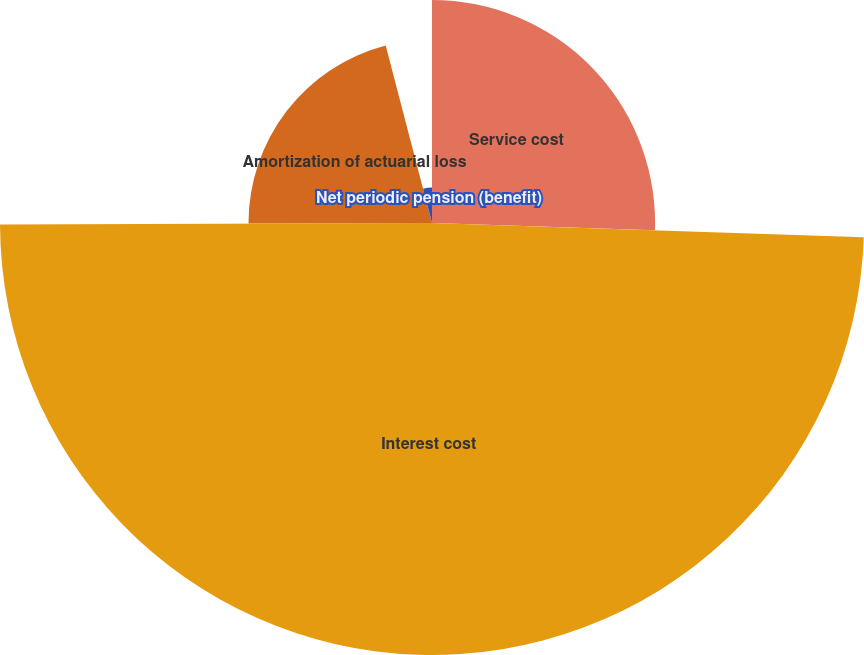<chart> <loc_0><loc_0><loc_500><loc_500><pie_chart><fcel>Service cost<fcel>Interest cost<fcel>Amortization of actuarial loss<fcel>Net periodic pension (benefit)<nl><fcel>25.52%<fcel>49.42%<fcel>20.99%<fcel>4.06%<nl></chart> 